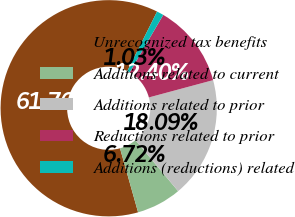<chart> <loc_0><loc_0><loc_500><loc_500><pie_chart><fcel>Unrecognized tax benefits<fcel>Additions related to current<fcel>Additions related to prior<fcel>Reductions related to prior<fcel>Additions (reductions) related<nl><fcel>61.77%<fcel>6.72%<fcel>18.09%<fcel>12.4%<fcel>1.03%<nl></chart> 